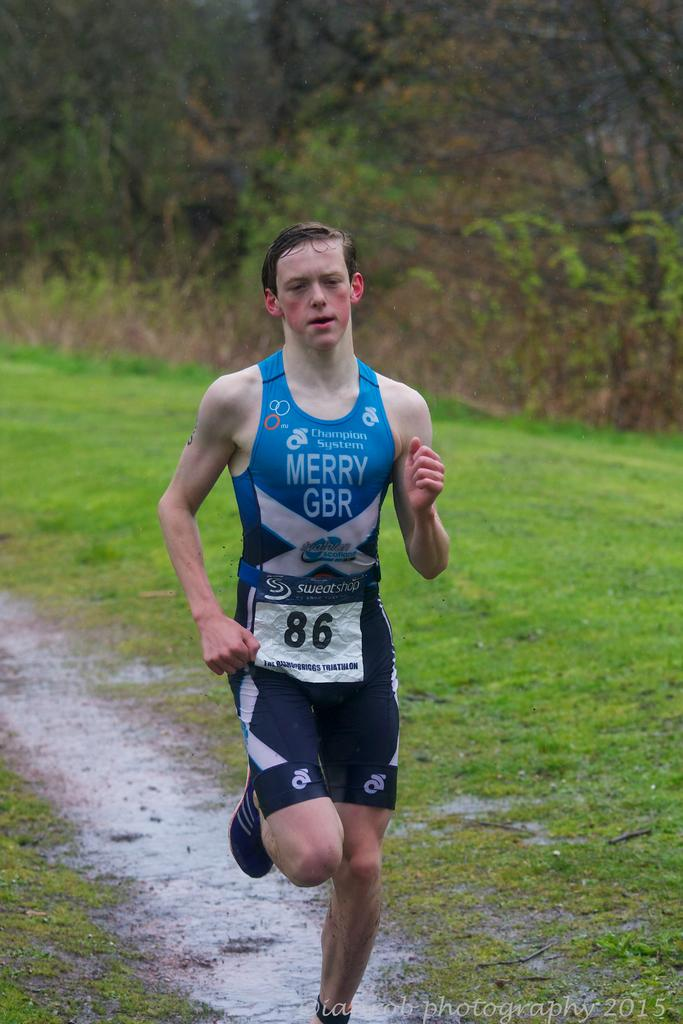Provide a one-sentence caption for the provided image. A man with number 86 attached to his Merry GBR jersey is running in a field. 